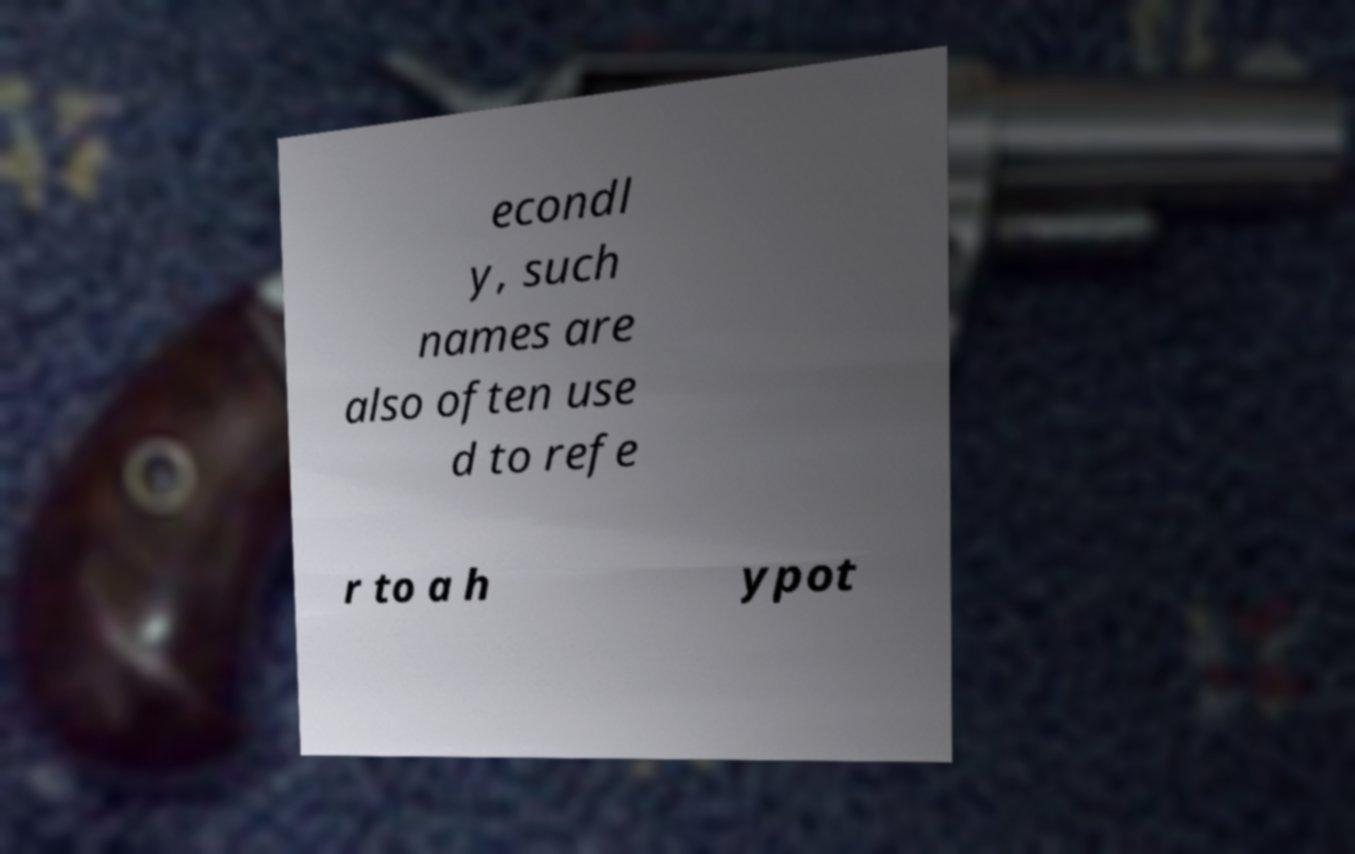Can you read and provide the text displayed in the image?This photo seems to have some interesting text. Can you extract and type it out for me? econdl y, such names are also often use d to refe r to a h ypot 